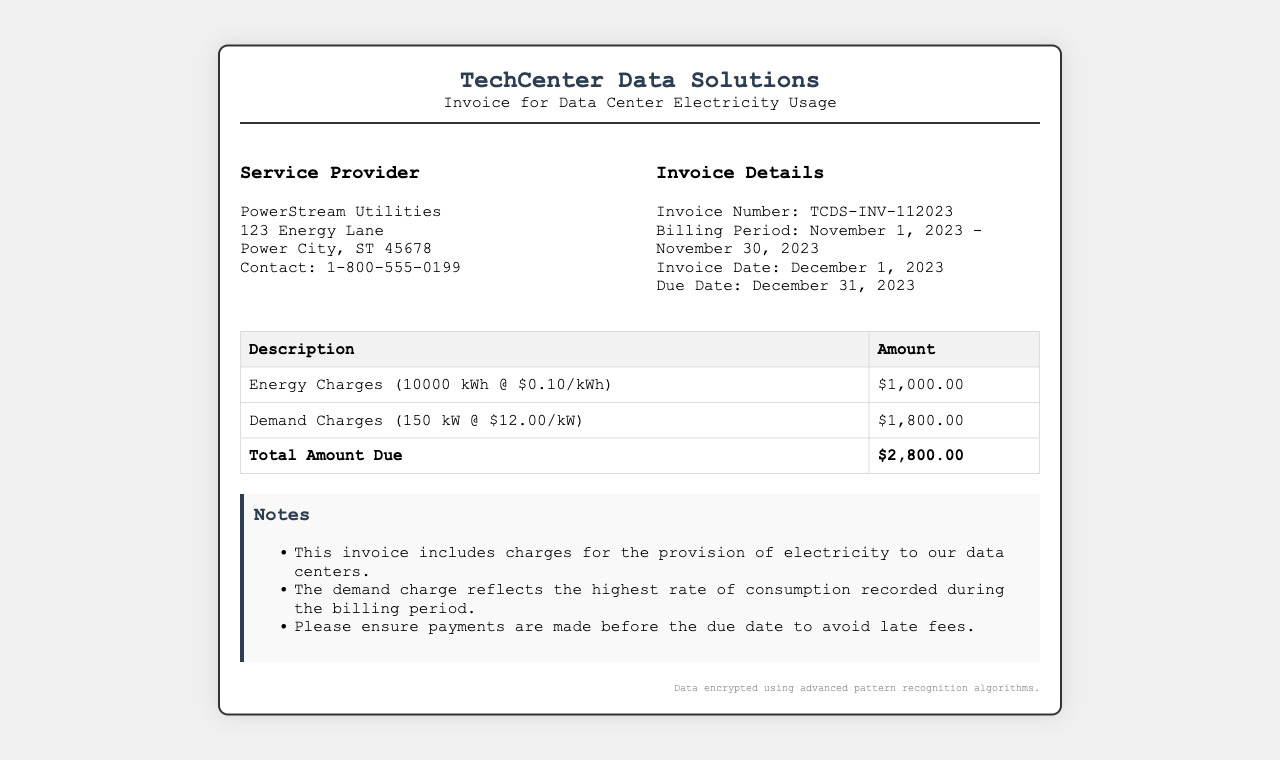What is the total amount due? The total amount due is provided in the invoice as the final price calculated from charges, which is $2,800.00.
Answer: $2,800.00 What is the billing period? The billing period indicates the time frame for the charges applied, which is stated as November 1, 2023 - November 30, 2023.
Answer: November 1, 2023 - November 30, 2023 How many kilowatt-hours were consumed? The energy charges reflect the total consumption in kilowatt-hours, which is mentioned as 10,000 kWh.
Answer: 10,000 kWh What is the invoice date? The invoice date is the date when the invoice was generated, which is given as December 1, 2023.
Answer: December 1, 2023 What charge corresponds to demand usage? The document specifies the demand charge in the invoice, which is calculated for 150 kW.
Answer: 150 kW What is the cost per kilowatt-hour? The cost rate for energy consumption is specifically listed in the invoice as $0.10 per kWh.
Answer: $0.10/kWh Who is the service provider? The service provider's name is clearly stated at the top, which is PowerStream Utilities.
Answer: PowerStream Utilities What is the due date for payment? The due date for payment is essential for customers to know and is indicated as December 31, 2023.
Answer: December 31, 2023 What type of charges are included in this invoice? The invoice details two types of charges: Energy Charges and Demand Charges, reflecting different aspects of electricity usage.
Answer: Energy Charges, Demand Charges 